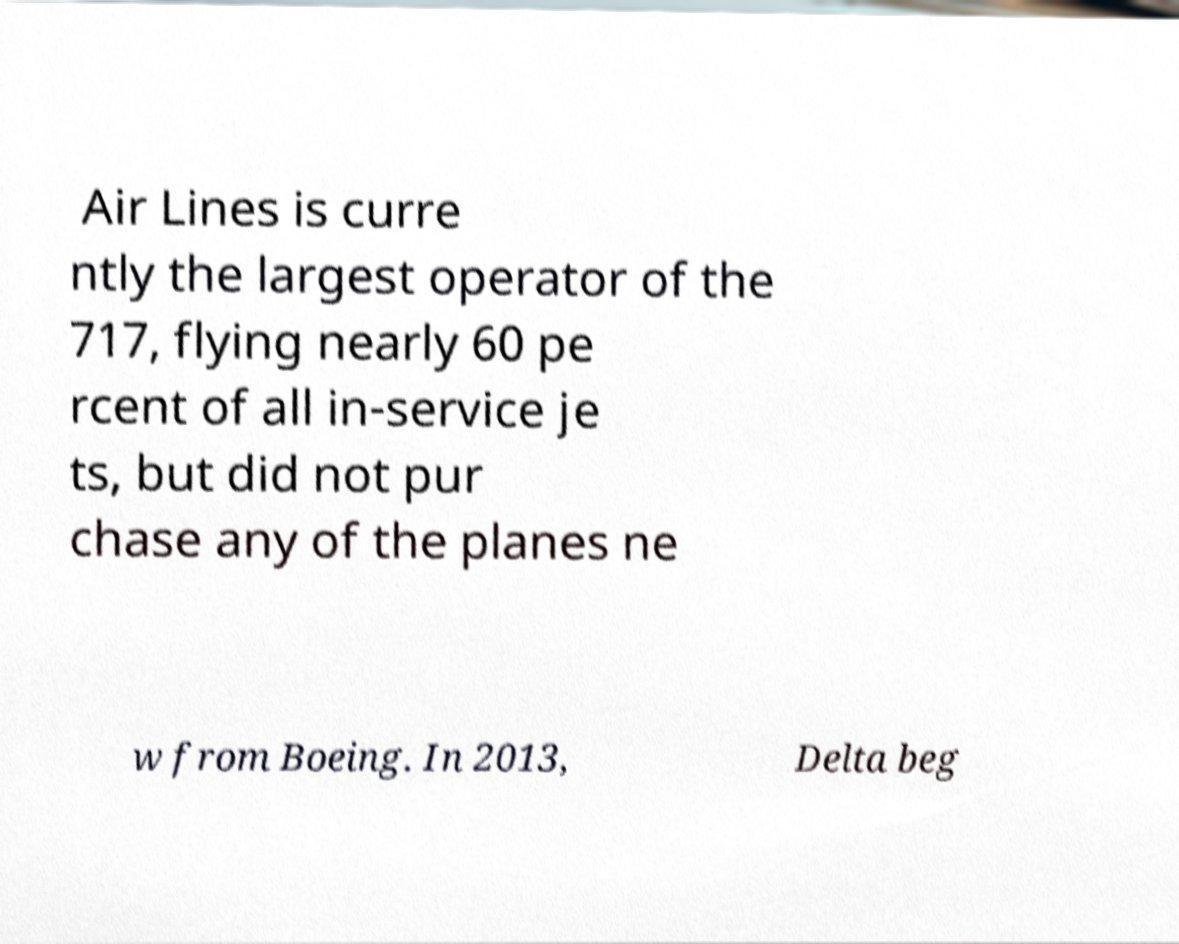Could you assist in decoding the text presented in this image and type it out clearly? Air Lines is curre ntly the largest operator of the 717, flying nearly 60 pe rcent of all in-service je ts, but did not pur chase any of the planes ne w from Boeing. In 2013, Delta beg 